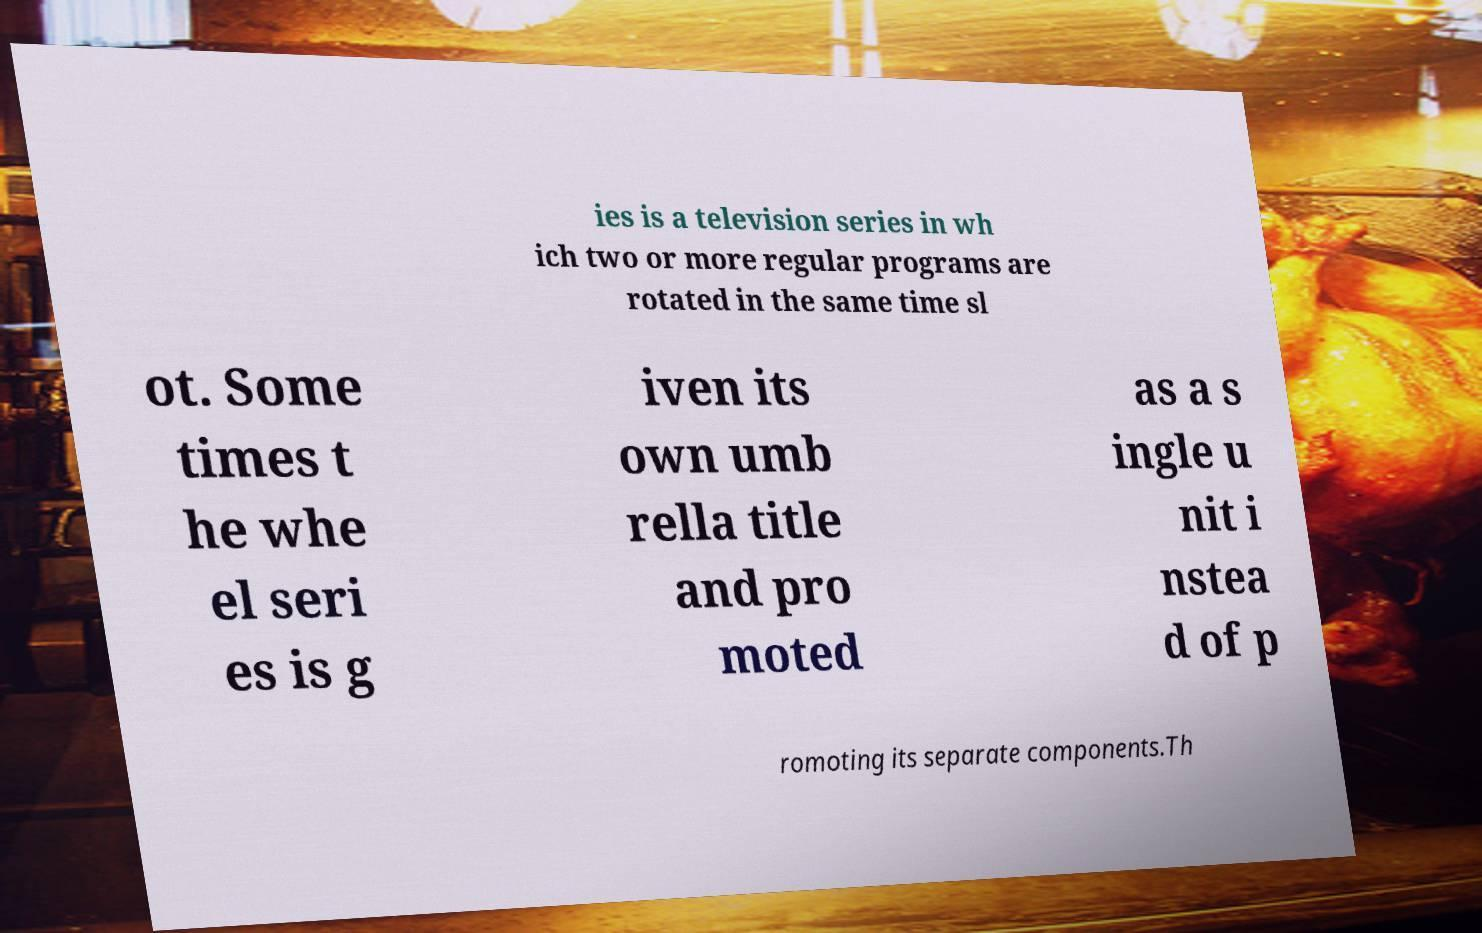What messages or text are displayed in this image? I need them in a readable, typed format. ies is a television series in wh ich two or more regular programs are rotated in the same time sl ot. Some times t he whe el seri es is g iven its own umb rella title and pro moted as a s ingle u nit i nstea d of p romoting its separate components.Th 